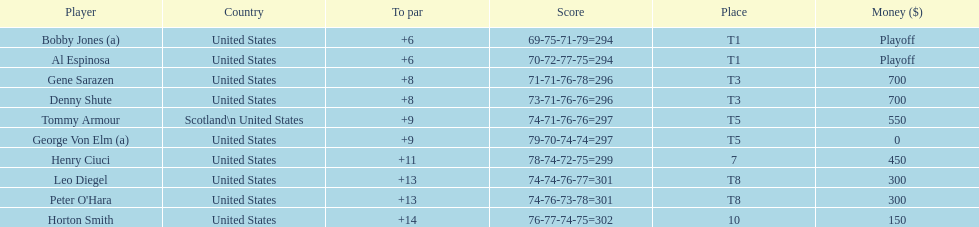Who finished next after bobby jones and al espinosa? Gene Sarazen, Denny Shute. 